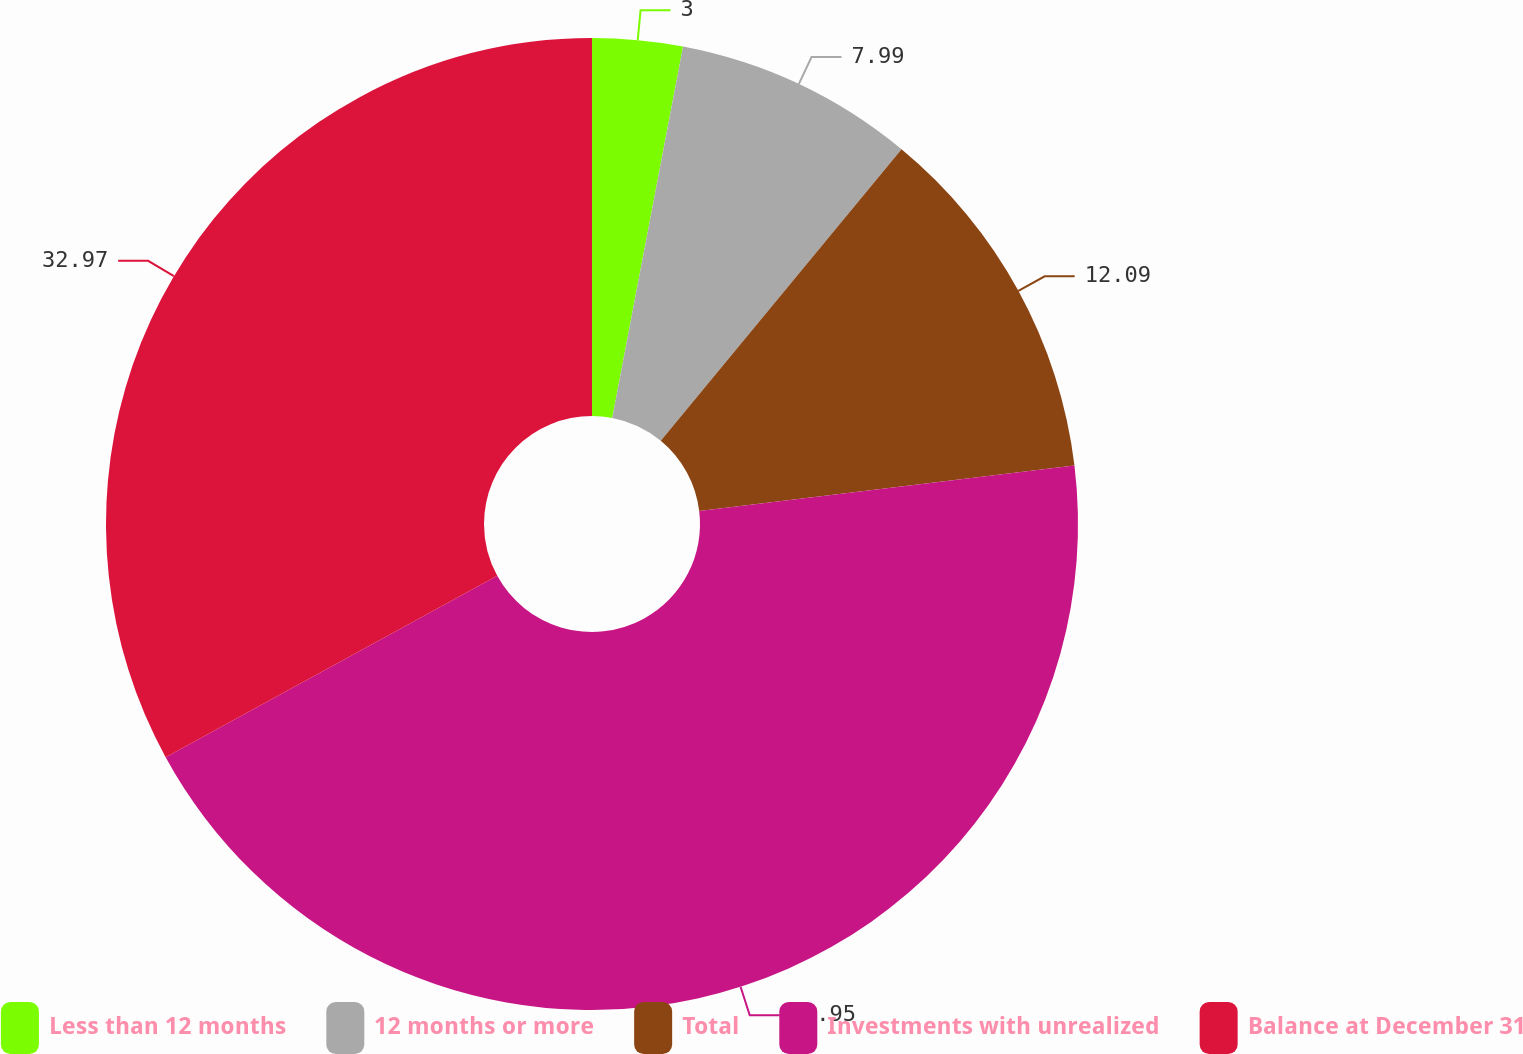Convert chart. <chart><loc_0><loc_0><loc_500><loc_500><pie_chart><fcel>Less than 12 months<fcel>12 months or more<fcel>Total<fcel>Investments with unrealized<fcel>Balance at December 31<nl><fcel>3.0%<fcel>7.99%<fcel>12.09%<fcel>43.96%<fcel>32.97%<nl></chart> 